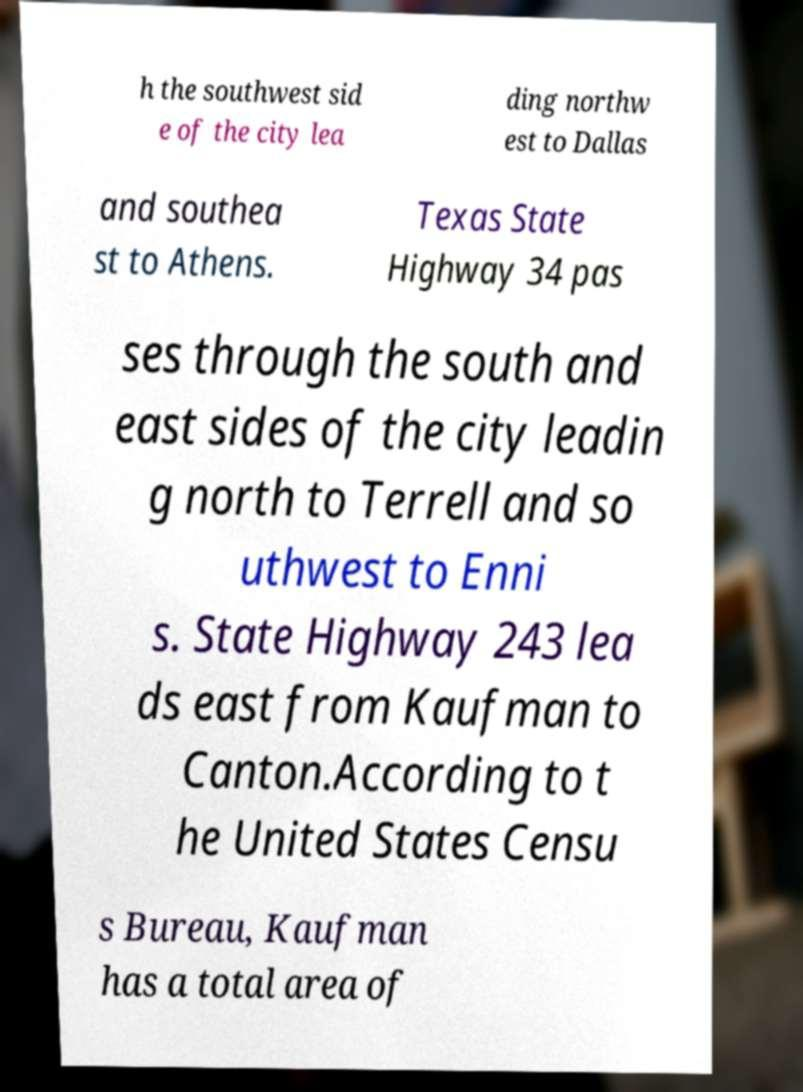Please read and relay the text visible in this image. What does it say? h the southwest sid e of the city lea ding northw est to Dallas and southea st to Athens. Texas State Highway 34 pas ses through the south and east sides of the city leadin g north to Terrell and so uthwest to Enni s. State Highway 243 lea ds east from Kaufman to Canton.According to t he United States Censu s Bureau, Kaufman has a total area of 